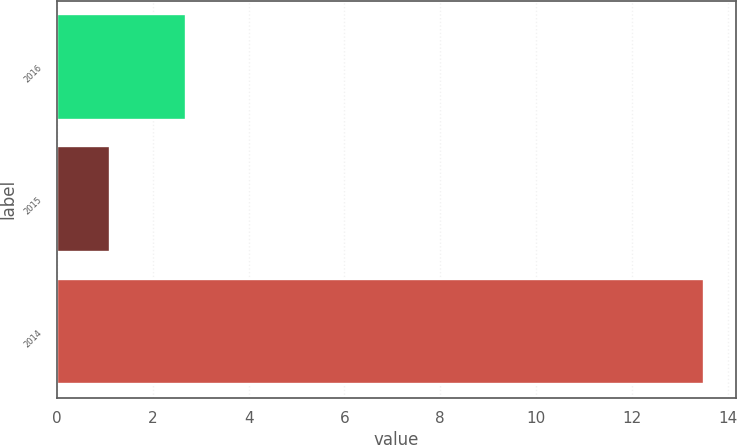<chart> <loc_0><loc_0><loc_500><loc_500><bar_chart><fcel>2016<fcel>2015<fcel>2014<nl><fcel>2.7<fcel>1.1<fcel>13.5<nl></chart> 